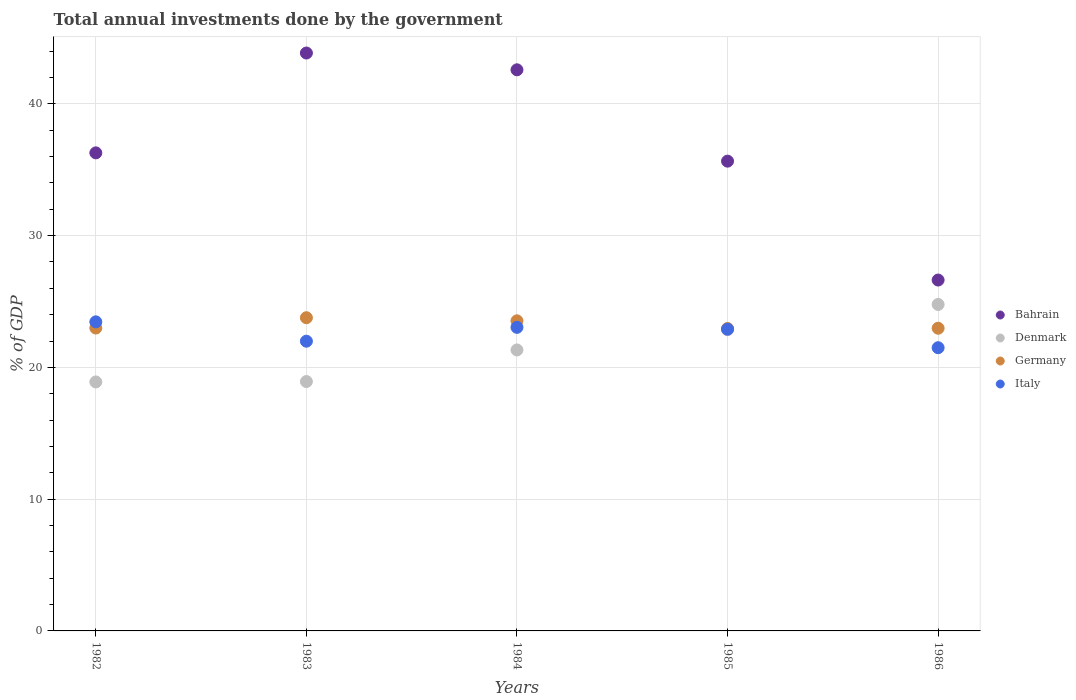How many different coloured dotlines are there?
Offer a very short reply. 4. What is the total annual investments done by the government in Germany in 1982?
Your answer should be very brief. 22.99. Across all years, what is the maximum total annual investments done by the government in Germany?
Ensure brevity in your answer.  23.77. Across all years, what is the minimum total annual investments done by the government in Germany?
Make the answer very short. 22.95. In which year was the total annual investments done by the government in Germany maximum?
Offer a very short reply. 1983. What is the total total annual investments done by the government in Germany in the graph?
Give a very brief answer. 116.21. What is the difference between the total annual investments done by the government in Germany in 1984 and that in 1985?
Ensure brevity in your answer.  0.58. What is the difference between the total annual investments done by the government in Denmark in 1983 and the total annual investments done by the government in Bahrain in 1986?
Your answer should be very brief. -7.7. What is the average total annual investments done by the government in Italy per year?
Provide a succinct answer. 22.57. In the year 1982, what is the difference between the total annual investments done by the government in Italy and total annual investments done by the government in Denmark?
Give a very brief answer. 4.56. In how many years, is the total annual investments done by the government in Denmark greater than 14 %?
Your answer should be very brief. 5. What is the ratio of the total annual investments done by the government in Italy in 1984 to that in 1985?
Offer a terse response. 1.01. Is the total annual investments done by the government in Italy in 1982 less than that in 1983?
Provide a succinct answer. No. Is the difference between the total annual investments done by the government in Italy in 1984 and 1986 greater than the difference between the total annual investments done by the government in Denmark in 1984 and 1986?
Provide a short and direct response. Yes. What is the difference between the highest and the second highest total annual investments done by the government in Italy?
Provide a short and direct response. 0.42. What is the difference between the highest and the lowest total annual investments done by the government in Denmark?
Your answer should be very brief. 5.88. In how many years, is the total annual investments done by the government in Bahrain greater than the average total annual investments done by the government in Bahrain taken over all years?
Your response must be concise. 2. Is the sum of the total annual investments done by the government in Germany in 1985 and 1986 greater than the maximum total annual investments done by the government in Denmark across all years?
Offer a very short reply. Yes. Is it the case that in every year, the sum of the total annual investments done by the government in Italy and total annual investments done by the government in Bahrain  is greater than the sum of total annual investments done by the government in Denmark and total annual investments done by the government in Germany?
Ensure brevity in your answer.  Yes. What is the difference between two consecutive major ticks on the Y-axis?
Provide a succinct answer. 10. Does the graph contain any zero values?
Give a very brief answer. No. Does the graph contain grids?
Keep it short and to the point. Yes. What is the title of the graph?
Provide a short and direct response. Total annual investments done by the government. What is the label or title of the Y-axis?
Provide a short and direct response. % of GDP. What is the % of GDP of Bahrain in 1982?
Your answer should be very brief. 36.28. What is the % of GDP of Denmark in 1982?
Make the answer very short. 18.89. What is the % of GDP in Germany in 1982?
Offer a very short reply. 22.99. What is the % of GDP in Italy in 1982?
Offer a very short reply. 23.45. What is the % of GDP in Bahrain in 1983?
Ensure brevity in your answer.  43.86. What is the % of GDP in Denmark in 1983?
Your answer should be compact. 18.92. What is the % of GDP of Germany in 1983?
Give a very brief answer. 23.77. What is the % of GDP in Italy in 1983?
Your response must be concise. 21.99. What is the % of GDP in Bahrain in 1984?
Ensure brevity in your answer.  42.58. What is the % of GDP in Denmark in 1984?
Your response must be concise. 21.32. What is the % of GDP in Germany in 1984?
Offer a very short reply. 23.53. What is the % of GDP in Italy in 1984?
Keep it short and to the point. 23.04. What is the % of GDP of Bahrain in 1985?
Your answer should be compact. 35.65. What is the % of GDP in Denmark in 1985?
Provide a short and direct response. 22.86. What is the % of GDP in Germany in 1985?
Provide a succinct answer. 22.95. What is the % of GDP of Italy in 1985?
Provide a succinct answer. 22.9. What is the % of GDP in Bahrain in 1986?
Provide a short and direct response. 26.63. What is the % of GDP in Denmark in 1986?
Provide a succinct answer. 24.77. What is the % of GDP in Germany in 1986?
Give a very brief answer. 22.97. What is the % of GDP of Italy in 1986?
Give a very brief answer. 21.49. Across all years, what is the maximum % of GDP in Bahrain?
Give a very brief answer. 43.86. Across all years, what is the maximum % of GDP in Denmark?
Give a very brief answer. 24.77. Across all years, what is the maximum % of GDP in Germany?
Provide a succinct answer. 23.77. Across all years, what is the maximum % of GDP of Italy?
Offer a very short reply. 23.45. Across all years, what is the minimum % of GDP of Bahrain?
Your answer should be very brief. 26.63. Across all years, what is the minimum % of GDP of Denmark?
Your answer should be compact. 18.89. Across all years, what is the minimum % of GDP of Germany?
Your answer should be compact. 22.95. Across all years, what is the minimum % of GDP of Italy?
Offer a terse response. 21.49. What is the total % of GDP in Bahrain in the graph?
Offer a very short reply. 184.99. What is the total % of GDP of Denmark in the graph?
Provide a short and direct response. 106.78. What is the total % of GDP of Germany in the graph?
Offer a terse response. 116.21. What is the total % of GDP of Italy in the graph?
Ensure brevity in your answer.  112.87. What is the difference between the % of GDP of Bahrain in 1982 and that in 1983?
Offer a terse response. -7.58. What is the difference between the % of GDP of Denmark in 1982 and that in 1983?
Your response must be concise. -0.03. What is the difference between the % of GDP in Germany in 1982 and that in 1983?
Give a very brief answer. -0.78. What is the difference between the % of GDP of Italy in 1982 and that in 1983?
Make the answer very short. 1.47. What is the difference between the % of GDP of Bahrain in 1982 and that in 1984?
Offer a very short reply. -6.3. What is the difference between the % of GDP in Denmark in 1982 and that in 1984?
Provide a succinct answer. -2.43. What is the difference between the % of GDP of Germany in 1982 and that in 1984?
Provide a short and direct response. -0.55. What is the difference between the % of GDP of Italy in 1982 and that in 1984?
Offer a terse response. 0.42. What is the difference between the % of GDP in Bahrain in 1982 and that in 1985?
Provide a short and direct response. 0.63. What is the difference between the % of GDP in Denmark in 1982 and that in 1985?
Your answer should be compact. -3.97. What is the difference between the % of GDP in Germany in 1982 and that in 1985?
Make the answer very short. 0.04. What is the difference between the % of GDP of Italy in 1982 and that in 1985?
Keep it short and to the point. 0.56. What is the difference between the % of GDP of Bahrain in 1982 and that in 1986?
Your response must be concise. 9.65. What is the difference between the % of GDP of Denmark in 1982 and that in 1986?
Offer a terse response. -5.88. What is the difference between the % of GDP of Germany in 1982 and that in 1986?
Your answer should be very brief. 0.02. What is the difference between the % of GDP in Italy in 1982 and that in 1986?
Keep it short and to the point. 1.96. What is the difference between the % of GDP of Bahrain in 1983 and that in 1984?
Your answer should be compact. 1.27. What is the difference between the % of GDP of Denmark in 1983 and that in 1984?
Provide a succinct answer. -2.4. What is the difference between the % of GDP of Germany in 1983 and that in 1984?
Your answer should be very brief. 0.24. What is the difference between the % of GDP in Italy in 1983 and that in 1984?
Make the answer very short. -1.05. What is the difference between the % of GDP of Bahrain in 1983 and that in 1985?
Provide a short and direct response. 8.21. What is the difference between the % of GDP in Denmark in 1983 and that in 1985?
Your answer should be compact. -3.94. What is the difference between the % of GDP in Germany in 1983 and that in 1985?
Provide a succinct answer. 0.82. What is the difference between the % of GDP in Italy in 1983 and that in 1985?
Provide a succinct answer. -0.91. What is the difference between the % of GDP of Bahrain in 1983 and that in 1986?
Provide a succinct answer. 17.23. What is the difference between the % of GDP of Denmark in 1983 and that in 1986?
Keep it short and to the point. -5.85. What is the difference between the % of GDP in Germany in 1983 and that in 1986?
Give a very brief answer. 0.8. What is the difference between the % of GDP in Italy in 1983 and that in 1986?
Make the answer very short. 0.49. What is the difference between the % of GDP in Bahrain in 1984 and that in 1985?
Offer a terse response. 6.93. What is the difference between the % of GDP of Denmark in 1984 and that in 1985?
Provide a succinct answer. -1.54. What is the difference between the % of GDP of Germany in 1984 and that in 1985?
Your answer should be compact. 0.58. What is the difference between the % of GDP in Italy in 1984 and that in 1985?
Ensure brevity in your answer.  0.14. What is the difference between the % of GDP of Bahrain in 1984 and that in 1986?
Ensure brevity in your answer.  15.95. What is the difference between the % of GDP of Denmark in 1984 and that in 1986?
Your answer should be very brief. -3.45. What is the difference between the % of GDP of Germany in 1984 and that in 1986?
Ensure brevity in your answer.  0.56. What is the difference between the % of GDP in Italy in 1984 and that in 1986?
Give a very brief answer. 1.55. What is the difference between the % of GDP of Bahrain in 1985 and that in 1986?
Your answer should be compact. 9.02. What is the difference between the % of GDP in Denmark in 1985 and that in 1986?
Offer a terse response. -1.91. What is the difference between the % of GDP of Germany in 1985 and that in 1986?
Provide a succinct answer. -0.02. What is the difference between the % of GDP of Italy in 1985 and that in 1986?
Your answer should be very brief. 1.41. What is the difference between the % of GDP in Bahrain in 1982 and the % of GDP in Denmark in 1983?
Offer a very short reply. 17.35. What is the difference between the % of GDP of Bahrain in 1982 and the % of GDP of Germany in 1983?
Ensure brevity in your answer.  12.51. What is the difference between the % of GDP of Bahrain in 1982 and the % of GDP of Italy in 1983?
Offer a very short reply. 14.29. What is the difference between the % of GDP of Denmark in 1982 and the % of GDP of Germany in 1983?
Offer a very short reply. -4.87. What is the difference between the % of GDP in Denmark in 1982 and the % of GDP in Italy in 1983?
Offer a very short reply. -3.09. What is the difference between the % of GDP of Bahrain in 1982 and the % of GDP of Denmark in 1984?
Give a very brief answer. 14.96. What is the difference between the % of GDP of Bahrain in 1982 and the % of GDP of Germany in 1984?
Your answer should be compact. 12.75. What is the difference between the % of GDP of Bahrain in 1982 and the % of GDP of Italy in 1984?
Your answer should be compact. 13.24. What is the difference between the % of GDP in Denmark in 1982 and the % of GDP in Germany in 1984?
Ensure brevity in your answer.  -4.64. What is the difference between the % of GDP of Denmark in 1982 and the % of GDP of Italy in 1984?
Make the answer very short. -4.14. What is the difference between the % of GDP of Germany in 1982 and the % of GDP of Italy in 1984?
Provide a short and direct response. -0.05. What is the difference between the % of GDP in Bahrain in 1982 and the % of GDP in Denmark in 1985?
Keep it short and to the point. 13.42. What is the difference between the % of GDP of Bahrain in 1982 and the % of GDP of Germany in 1985?
Make the answer very short. 13.33. What is the difference between the % of GDP of Bahrain in 1982 and the % of GDP of Italy in 1985?
Keep it short and to the point. 13.38. What is the difference between the % of GDP of Denmark in 1982 and the % of GDP of Germany in 1985?
Offer a very short reply. -4.06. What is the difference between the % of GDP in Denmark in 1982 and the % of GDP in Italy in 1985?
Your answer should be very brief. -4. What is the difference between the % of GDP of Germany in 1982 and the % of GDP of Italy in 1985?
Provide a succinct answer. 0.09. What is the difference between the % of GDP in Bahrain in 1982 and the % of GDP in Denmark in 1986?
Your answer should be very brief. 11.5. What is the difference between the % of GDP in Bahrain in 1982 and the % of GDP in Germany in 1986?
Your response must be concise. 13.31. What is the difference between the % of GDP of Bahrain in 1982 and the % of GDP of Italy in 1986?
Make the answer very short. 14.79. What is the difference between the % of GDP in Denmark in 1982 and the % of GDP in Germany in 1986?
Offer a very short reply. -4.08. What is the difference between the % of GDP of Denmark in 1982 and the % of GDP of Italy in 1986?
Offer a very short reply. -2.6. What is the difference between the % of GDP of Germany in 1982 and the % of GDP of Italy in 1986?
Make the answer very short. 1.49. What is the difference between the % of GDP of Bahrain in 1983 and the % of GDP of Denmark in 1984?
Give a very brief answer. 22.53. What is the difference between the % of GDP of Bahrain in 1983 and the % of GDP of Germany in 1984?
Your answer should be very brief. 20.32. What is the difference between the % of GDP of Bahrain in 1983 and the % of GDP of Italy in 1984?
Your response must be concise. 20.82. What is the difference between the % of GDP in Denmark in 1983 and the % of GDP in Germany in 1984?
Provide a short and direct response. -4.61. What is the difference between the % of GDP of Denmark in 1983 and the % of GDP of Italy in 1984?
Your answer should be very brief. -4.11. What is the difference between the % of GDP in Germany in 1983 and the % of GDP in Italy in 1984?
Your response must be concise. 0.73. What is the difference between the % of GDP in Bahrain in 1983 and the % of GDP in Denmark in 1985?
Your response must be concise. 20.99. What is the difference between the % of GDP in Bahrain in 1983 and the % of GDP in Germany in 1985?
Provide a short and direct response. 20.91. What is the difference between the % of GDP of Bahrain in 1983 and the % of GDP of Italy in 1985?
Offer a terse response. 20.96. What is the difference between the % of GDP of Denmark in 1983 and the % of GDP of Germany in 1985?
Your answer should be compact. -4.03. What is the difference between the % of GDP of Denmark in 1983 and the % of GDP of Italy in 1985?
Ensure brevity in your answer.  -3.97. What is the difference between the % of GDP of Germany in 1983 and the % of GDP of Italy in 1985?
Offer a very short reply. 0.87. What is the difference between the % of GDP of Bahrain in 1983 and the % of GDP of Denmark in 1986?
Your response must be concise. 19.08. What is the difference between the % of GDP in Bahrain in 1983 and the % of GDP in Germany in 1986?
Offer a very short reply. 20.89. What is the difference between the % of GDP in Bahrain in 1983 and the % of GDP in Italy in 1986?
Your response must be concise. 22.36. What is the difference between the % of GDP of Denmark in 1983 and the % of GDP of Germany in 1986?
Provide a succinct answer. -4.05. What is the difference between the % of GDP of Denmark in 1983 and the % of GDP of Italy in 1986?
Keep it short and to the point. -2.57. What is the difference between the % of GDP of Germany in 1983 and the % of GDP of Italy in 1986?
Your answer should be compact. 2.28. What is the difference between the % of GDP in Bahrain in 1984 and the % of GDP in Denmark in 1985?
Your answer should be compact. 19.72. What is the difference between the % of GDP of Bahrain in 1984 and the % of GDP of Germany in 1985?
Offer a terse response. 19.63. What is the difference between the % of GDP of Bahrain in 1984 and the % of GDP of Italy in 1985?
Give a very brief answer. 19.68. What is the difference between the % of GDP of Denmark in 1984 and the % of GDP of Germany in 1985?
Provide a succinct answer. -1.63. What is the difference between the % of GDP of Denmark in 1984 and the % of GDP of Italy in 1985?
Your answer should be compact. -1.58. What is the difference between the % of GDP of Germany in 1984 and the % of GDP of Italy in 1985?
Provide a short and direct response. 0.63. What is the difference between the % of GDP in Bahrain in 1984 and the % of GDP in Denmark in 1986?
Provide a succinct answer. 17.81. What is the difference between the % of GDP in Bahrain in 1984 and the % of GDP in Germany in 1986?
Your answer should be compact. 19.61. What is the difference between the % of GDP of Bahrain in 1984 and the % of GDP of Italy in 1986?
Offer a very short reply. 21.09. What is the difference between the % of GDP in Denmark in 1984 and the % of GDP in Germany in 1986?
Keep it short and to the point. -1.65. What is the difference between the % of GDP in Denmark in 1984 and the % of GDP in Italy in 1986?
Offer a very short reply. -0.17. What is the difference between the % of GDP of Germany in 1984 and the % of GDP of Italy in 1986?
Your response must be concise. 2.04. What is the difference between the % of GDP in Bahrain in 1985 and the % of GDP in Denmark in 1986?
Your response must be concise. 10.87. What is the difference between the % of GDP in Bahrain in 1985 and the % of GDP in Germany in 1986?
Your answer should be compact. 12.68. What is the difference between the % of GDP of Bahrain in 1985 and the % of GDP of Italy in 1986?
Keep it short and to the point. 14.16. What is the difference between the % of GDP of Denmark in 1985 and the % of GDP of Germany in 1986?
Give a very brief answer. -0.11. What is the difference between the % of GDP of Denmark in 1985 and the % of GDP of Italy in 1986?
Keep it short and to the point. 1.37. What is the difference between the % of GDP in Germany in 1985 and the % of GDP in Italy in 1986?
Give a very brief answer. 1.46. What is the average % of GDP of Bahrain per year?
Provide a short and direct response. 37. What is the average % of GDP of Denmark per year?
Your answer should be very brief. 21.36. What is the average % of GDP of Germany per year?
Keep it short and to the point. 23.24. What is the average % of GDP of Italy per year?
Give a very brief answer. 22.57. In the year 1982, what is the difference between the % of GDP of Bahrain and % of GDP of Denmark?
Give a very brief answer. 17.38. In the year 1982, what is the difference between the % of GDP of Bahrain and % of GDP of Germany?
Offer a terse response. 13.29. In the year 1982, what is the difference between the % of GDP of Bahrain and % of GDP of Italy?
Provide a succinct answer. 12.82. In the year 1982, what is the difference between the % of GDP of Denmark and % of GDP of Germany?
Make the answer very short. -4.09. In the year 1982, what is the difference between the % of GDP of Denmark and % of GDP of Italy?
Give a very brief answer. -4.56. In the year 1982, what is the difference between the % of GDP in Germany and % of GDP in Italy?
Provide a succinct answer. -0.47. In the year 1983, what is the difference between the % of GDP in Bahrain and % of GDP in Denmark?
Offer a terse response. 24.93. In the year 1983, what is the difference between the % of GDP of Bahrain and % of GDP of Germany?
Provide a succinct answer. 20.09. In the year 1983, what is the difference between the % of GDP in Bahrain and % of GDP in Italy?
Provide a succinct answer. 21.87. In the year 1983, what is the difference between the % of GDP in Denmark and % of GDP in Germany?
Give a very brief answer. -4.84. In the year 1983, what is the difference between the % of GDP in Denmark and % of GDP in Italy?
Provide a succinct answer. -3.06. In the year 1983, what is the difference between the % of GDP of Germany and % of GDP of Italy?
Your answer should be compact. 1.78. In the year 1984, what is the difference between the % of GDP of Bahrain and % of GDP of Denmark?
Make the answer very short. 21.26. In the year 1984, what is the difference between the % of GDP in Bahrain and % of GDP in Germany?
Provide a succinct answer. 19.05. In the year 1984, what is the difference between the % of GDP in Bahrain and % of GDP in Italy?
Your answer should be compact. 19.54. In the year 1984, what is the difference between the % of GDP of Denmark and % of GDP of Germany?
Provide a short and direct response. -2.21. In the year 1984, what is the difference between the % of GDP in Denmark and % of GDP in Italy?
Offer a terse response. -1.71. In the year 1984, what is the difference between the % of GDP in Germany and % of GDP in Italy?
Your answer should be very brief. 0.5. In the year 1985, what is the difference between the % of GDP in Bahrain and % of GDP in Denmark?
Your answer should be compact. 12.79. In the year 1985, what is the difference between the % of GDP in Bahrain and % of GDP in Germany?
Give a very brief answer. 12.7. In the year 1985, what is the difference between the % of GDP in Bahrain and % of GDP in Italy?
Your response must be concise. 12.75. In the year 1985, what is the difference between the % of GDP in Denmark and % of GDP in Germany?
Provide a succinct answer. -0.09. In the year 1985, what is the difference between the % of GDP of Denmark and % of GDP of Italy?
Give a very brief answer. -0.04. In the year 1985, what is the difference between the % of GDP of Germany and % of GDP of Italy?
Provide a succinct answer. 0.05. In the year 1986, what is the difference between the % of GDP of Bahrain and % of GDP of Denmark?
Offer a very short reply. 1.85. In the year 1986, what is the difference between the % of GDP in Bahrain and % of GDP in Germany?
Provide a short and direct response. 3.66. In the year 1986, what is the difference between the % of GDP of Bahrain and % of GDP of Italy?
Offer a very short reply. 5.14. In the year 1986, what is the difference between the % of GDP in Denmark and % of GDP in Germany?
Provide a succinct answer. 1.8. In the year 1986, what is the difference between the % of GDP in Denmark and % of GDP in Italy?
Keep it short and to the point. 3.28. In the year 1986, what is the difference between the % of GDP in Germany and % of GDP in Italy?
Offer a very short reply. 1.48. What is the ratio of the % of GDP of Bahrain in 1982 to that in 1983?
Your answer should be compact. 0.83. What is the ratio of the % of GDP of Denmark in 1982 to that in 1983?
Give a very brief answer. 1. What is the ratio of the % of GDP in Germany in 1982 to that in 1983?
Ensure brevity in your answer.  0.97. What is the ratio of the % of GDP in Italy in 1982 to that in 1983?
Make the answer very short. 1.07. What is the ratio of the % of GDP in Bahrain in 1982 to that in 1984?
Your answer should be compact. 0.85. What is the ratio of the % of GDP of Denmark in 1982 to that in 1984?
Give a very brief answer. 0.89. What is the ratio of the % of GDP of Germany in 1982 to that in 1984?
Provide a succinct answer. 0.98. What is the ratio of the % of GDP in Italy in 1982 to that in 1984?
Offer a terse response. 1.02. What is the ratio of the % of GDP in Bahrain in 1982 to that in 1985?
Offer a very short reply. 1.02. What is the ratio of the % of GDP in Denmark in 1982 to that in 1985?
Keep it short and to the point. 0.83. What is the ratio of the % of GDP in Germany in 1982 to that in 1985?
Offer a terse response. 1. What is the ratio of the % of GDP of Italy in 1982 to that in 1985?
Ensure brevity in your answer.  1.02. What is the ratio of the % of GDP in Bahrain in 1982 to that in 1986?
Give a very brief answer. 1.36. What is the ratio of the % of GDP of Denmark in 1982 to that in 1986?
Make the answer very short. 0.76. What is the ratio of the % of GDP in Germany in 1982 to that in 1986?
Give a very brief answer. 1. What is the ratio of the % of GDP in Italy in 1982 to that in 1986?
Offer a terse response. 1.09. What is the ratio of the % of GDP in Bahrain in 1983 to that in 1984?
Your response must be concise. 1.03. What is the ratio of the % of GDP in Denmark in 1983 to that in 1984?
Ensure brevity in your answer.  0.89. What is the ratio of the % of GDP in Germany in 1983 to that in 1984?
Keep it short and to the point. 1.01. What is the ratio of the % of GDP in Italy in 1983 to that in 1984?
Your answer should be compact. 0.95. What is the ratio of the % of GDP of Bahrain in 1983 to that in 1985?
Keep it short and to the point. 1.23. What is the ratio of the % of GDP in Denmark in 1983 to that in 1985?
Offer a terse response. 0.83. What is the ratio of the % of GDP of Germany in 1983 to that in 1985?
Offer a terse response. 1.04. What is the ratio of the % of GDP in Italy in 1983 to that in 1985?
Offer a very short reply. 0.96. What is the ratio of the % of GDP of Bahrain in 1983 to that in 1986?
Your answer should be compact. 1.65. What is the ratio of the % of GDP of Denmark in 1983 to that in 1986?
Ensure brevity in your answer.  0.76. What is the ratio of the % of GDP of Germany in 1983 to that in 1986?
Your answer should be compact. 1.03. What is the ratio of the % of GDP in Bahrain in 1984 to that in 1985?
Make the answer very short. 1.19. What is the ratio of the % of GDP in Denmark in 1984 to that in 1985?
Your answer should be compact. 0.93. What is the ratio of the % of GDP of Germany in 1984 to that in 1985?
Keep it short and to the point. 1.03. What is the ratio of the % of GDP of Italy in 1984 to that in 1985?
Offer a very short reply. 1.01. What is the ratio of the % of GDP in Bahrain in 1984 to that in 1986?
Make the answer very short. 1.6. What is the ratio of the % of GDP in Denmark in 1984 to that in 1986?
Offer a very short reply. 0.86. What is the ratio of the % of GDP in Germany in 1984 to that in 1986?
Provide a short and direct response. 1.02. What is the ratio of the % of GDP in Italy in 1984 to that in 1986?
Offer a very short reply. 1.07. What is the ratio of the % of GDP in Bahrain in 1985 to that in 1986?
Offer a terse response. 1.34. What is the ratio of the % of GDP in Denmark in 1985 to that in 1986?
Your response must be concise. 0.92. What is the ratio of the % of GDP of Italy in 1985 to that in 1986?
Offer a very short reply. 1.07. What is the difference between the highest and the second highest % of GDP in Bahrain?
Offer a very short reply. 1.27. What is the difference between the highest and the second highest % of GDP of Denmark?
Your answer should be compact. 1.91. What is the difference between the highest and the second highest % of GDP in Germany?
Your answer should be compact. 0.24. What is the difference between the highest and the second highest % of GDP of Italy?
Provide a succinct answer. 0.42. What is the difference between the highest and the lowest % of GDP in Bahrain?
Your response must be concise. 17.23. What is the difference between the highest and the lowest % of GDP in Denmark?
Provide a short and direct response. 5.88. What is the difference between the highest and the lowest % of GDP of Germany?
Ensure brevity in your answer.  0.82. What is the difference between the highest and the lowest % of GDP of Italy?
Your answer should be compact. 1.96. 